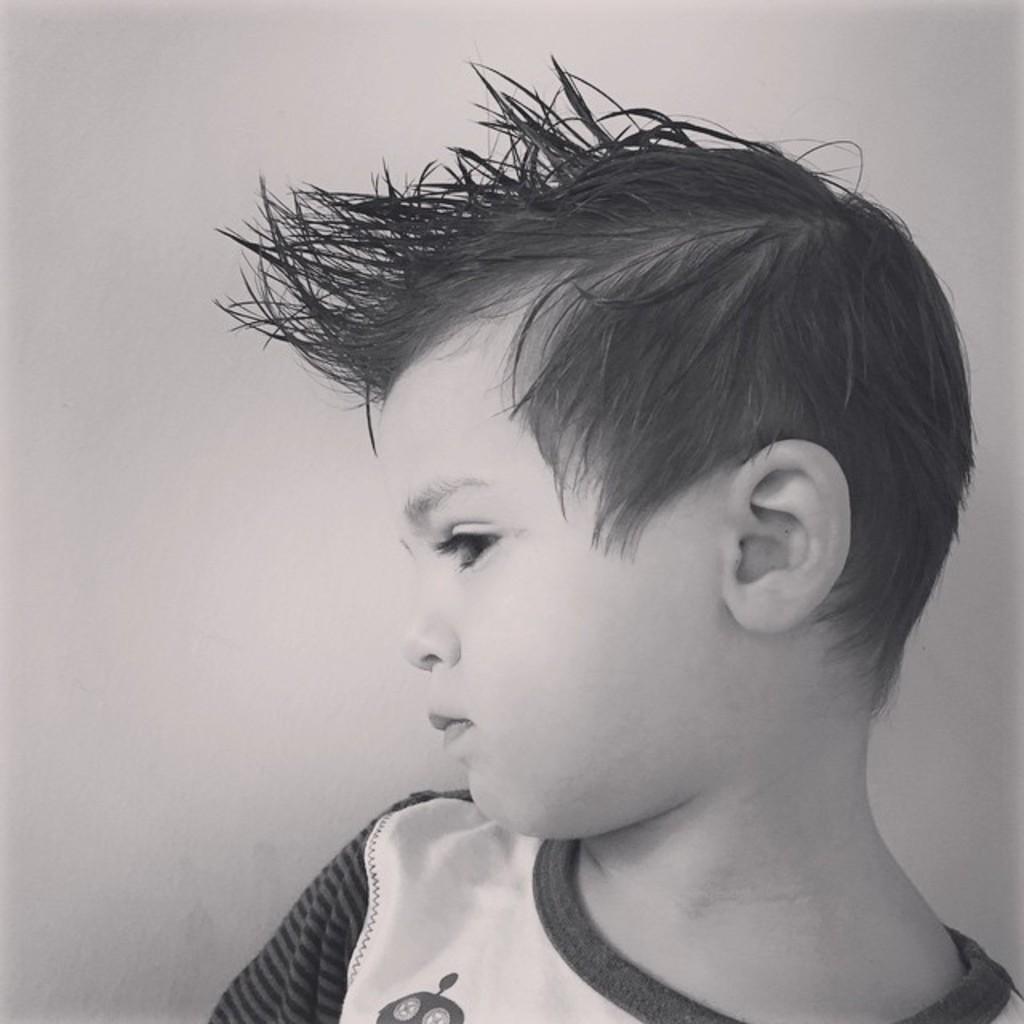Please provide a concise description of this image. This is a black and white image. In this image we can see a boy. In the background there is a wall. 